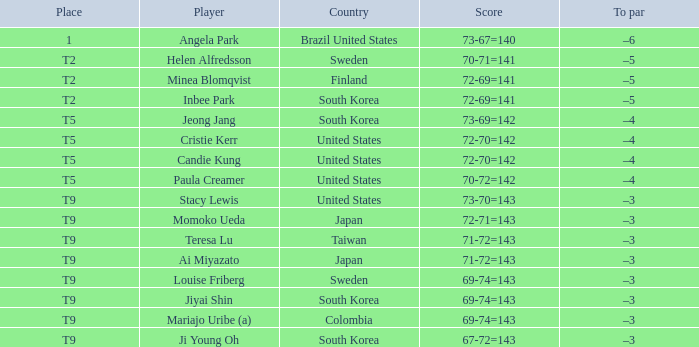What did Taiwan score? 71-72=143. 